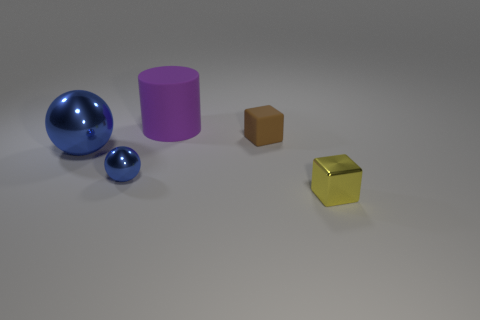Add 4 large gray objects. How many objects exist? 9 Subtract all cylinders. How many objects are left? 4 Add 4 brown matte cubes. How many brown matte cubes are left? 5 Add 5 big blue shiny objects. How many big blue shiny objects exist? 6 Subtract 0 green cylinders. How many objects are left? 5 Subtract all cubes. Subtract all tiny shiny spheres. How many objects are left? 2 